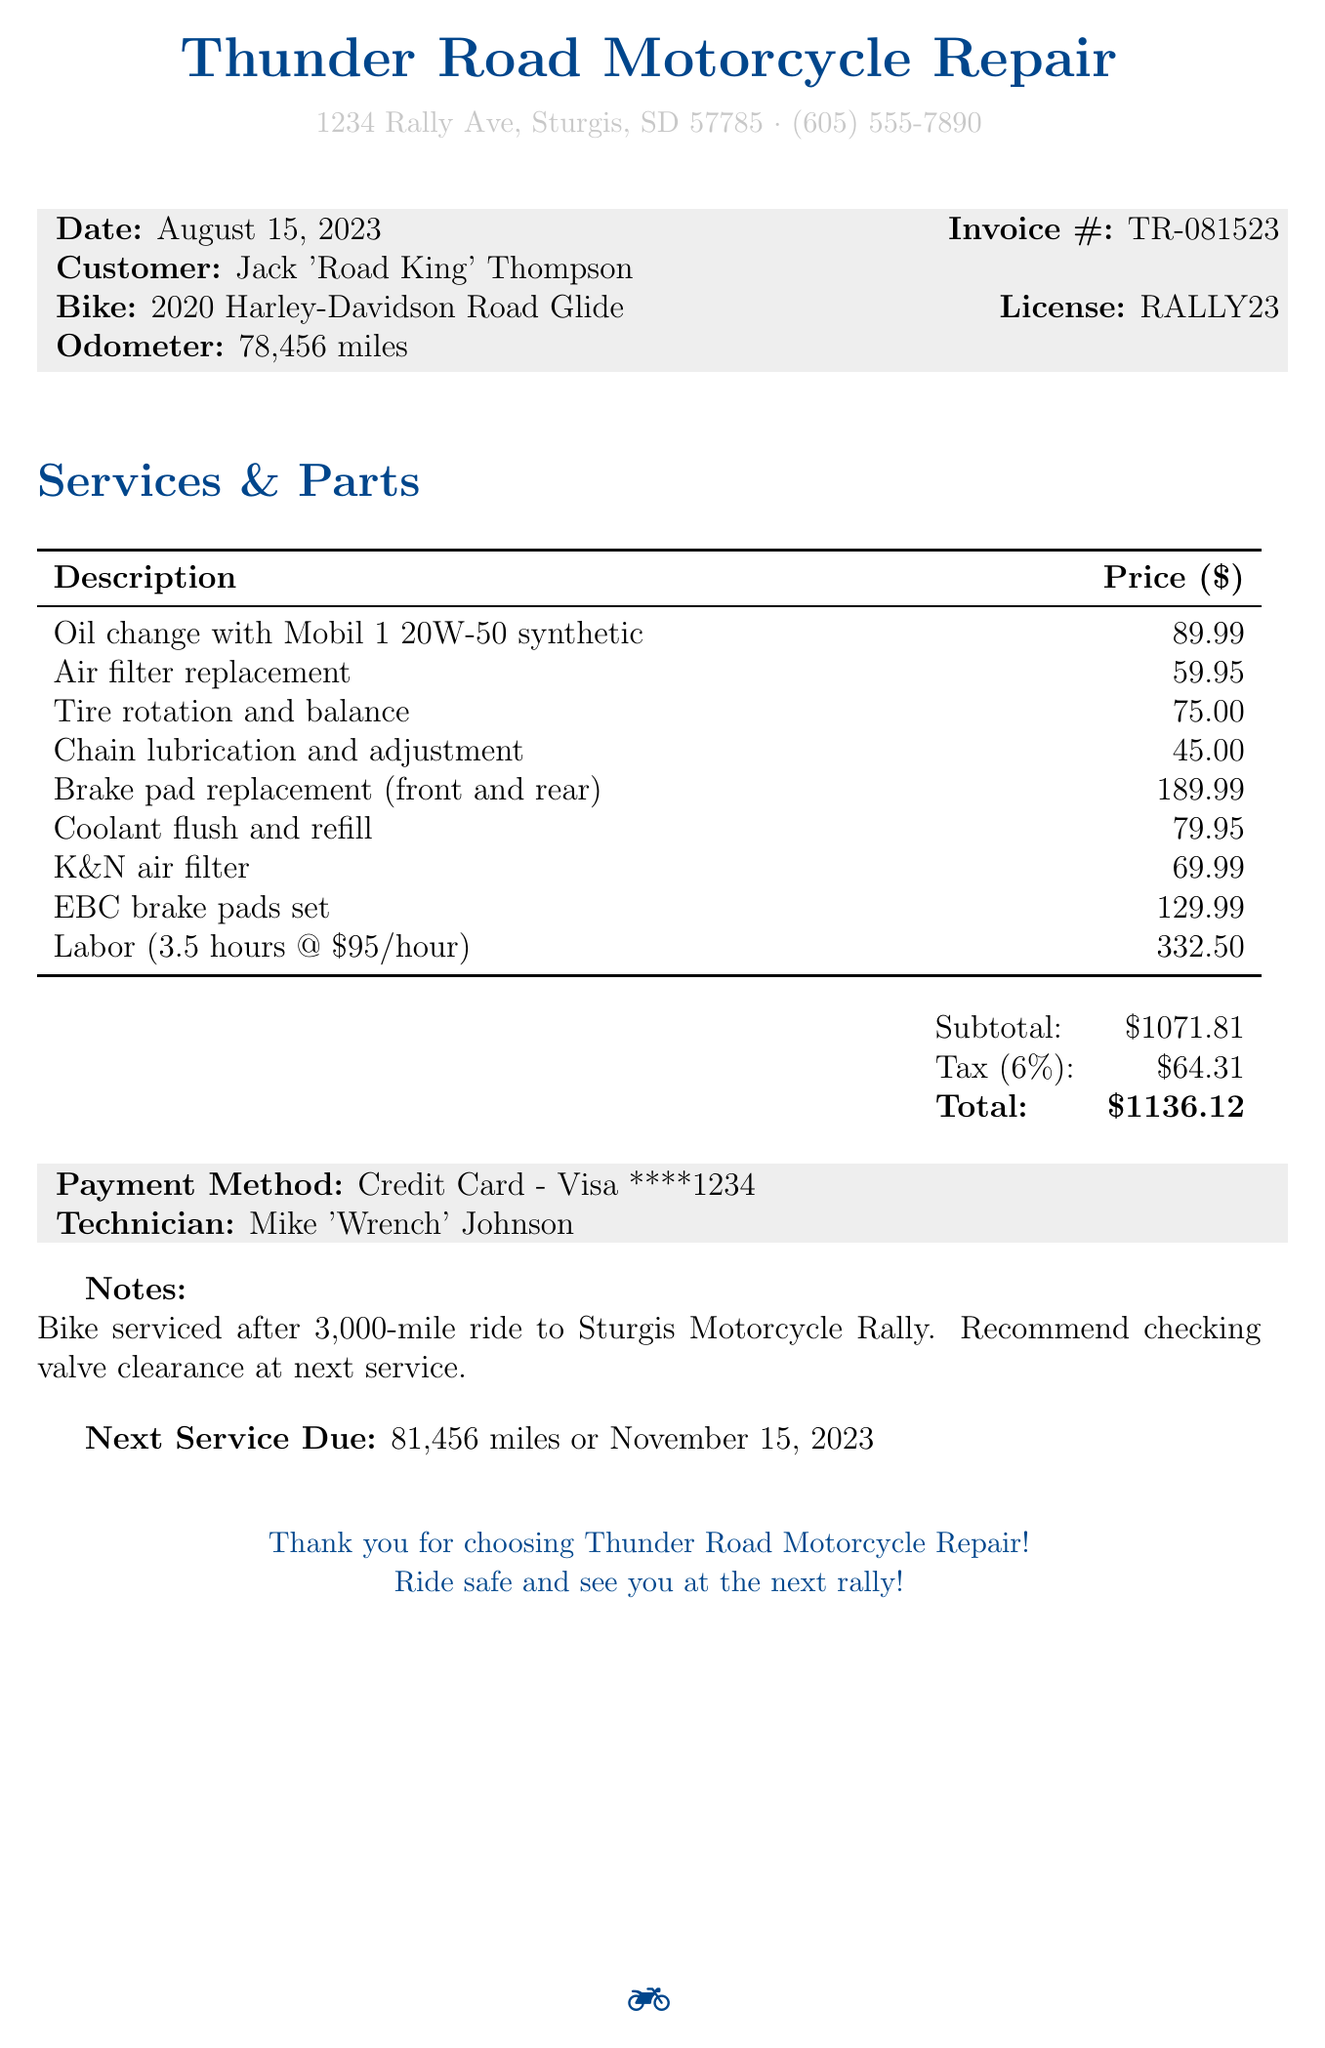What is the name of the repair shop? The name of the repair shop is stated at the top of the receipt.
Answer: Thunder Road Motorcycle Repair What is the date of the service? The date is clearly mentioned in the document.
Answer: August 15, 2023 Who is the customer? The customer's name is specified in the receipt.
Answer: Jack 'Road King' Thompson What is the total cost of the services? The total cost is presented at the end of the receipt.
Answer: $1136.12 How many hours of labor were charged? The number of labor hours is explicitly mentioned in the document.
Answer: 3.5 What is the bike model? The bike model is detailed in the information provided for the customer.
Answer: 2020 Harley-Davidson Road Glide What parts were purchased? The parts purchased are listed in the services and parts section.
Answer: K&N air filter, EBC brake pads set What is the recommended next service date? The next service due date is noted towards the end of the receipt.
Answer: November 15, 2023 Who performed the maintenance? The technician responsible for servicing the bike is mentioned.
Answer: Mike 'Wrench' Johnson 